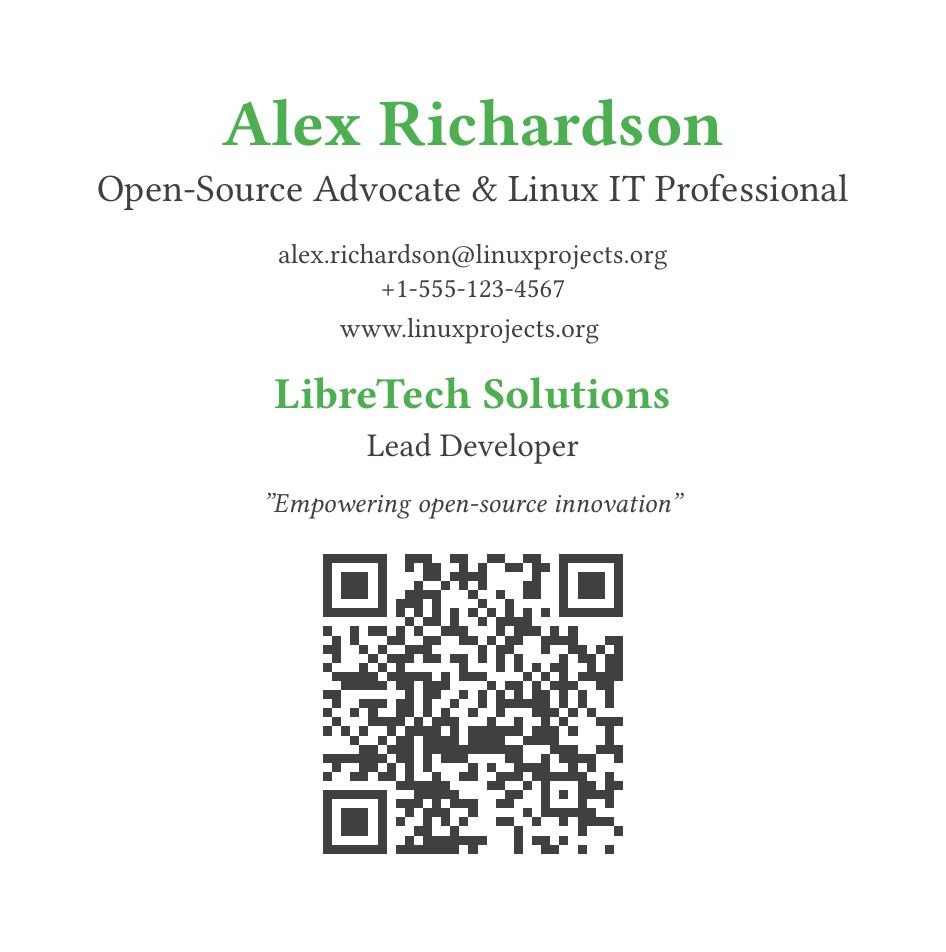What is the name on the business card? The document displays the name prominently at the top of the card.
Answer: Alex Richardson What is the title of the individual? The title is mentioned directly under the name, indicating the professional role of the individual.
Answer: Open-Source Advocate & Linux IT Professional What is the organization associated with the individual? The organization's name is listed in a larger font further down the card.
Answer: LibreTech Solutions What is the contact email address? The email address is provided in a standard format on the card.
Answer: alex.richardson@linuxprojects.org What is the phone number listed on the card? The document includes a phone number for contact purposes.
Answer: +1-555-123-4567 What is the tagline associated with the organization? The tagline is included in italicized text, summarizing the mission.
Answer: "Empowering open-source innovation" What repository does the QR code link to? The QR code is intended to direct users to the project's online repository.
Answer: https://github.com/LibreTechSolutions/main-repo What is the color scheme used in the business card? The document utilizes specific colors which are defined in the code section at the beginning.
Answer: Green and gray What type of document is this? The format and structure described are characteristic of a specific type of personal identification in professional contexts.
Answer: Business card 